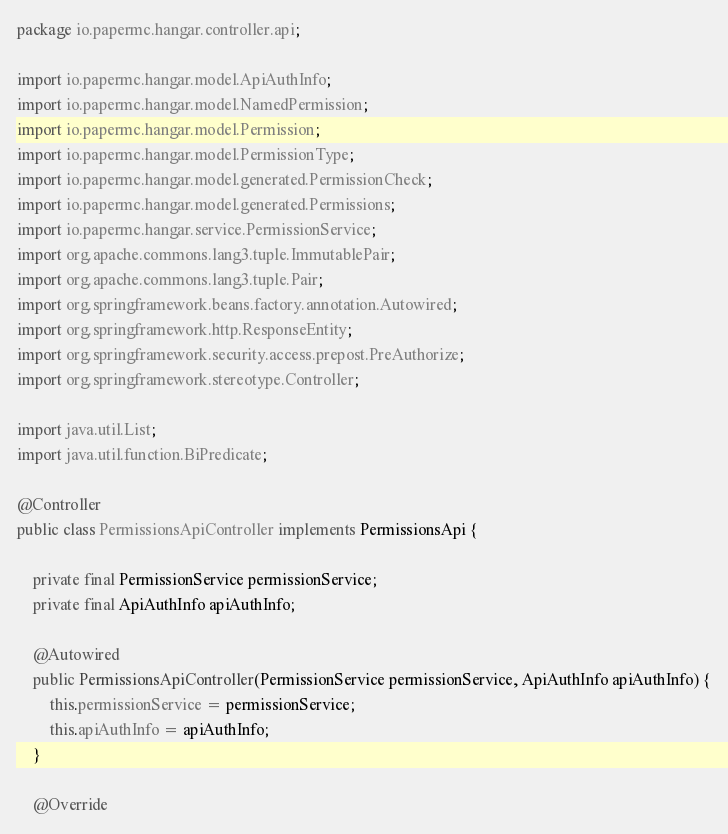<code> <loc_0><loc_0><loc_500><loc_500><_Java_>package io.papermc.hangar.controller.api;

import io.papermc.hangar.model.ApiAuthInfo;
import io.papermc.hangar.model.NamedPermission;
import io.papermc.hangar.model.Permission;
import io.papermc.hangar.model.PermissionType;
import io.papermc.hangar.model.generated.PermissionCheck;
import io.papermc.hangar.model.generated.Permissions;
import io.papermc.hangar.service.PermissionService;
import org.apache.commons.lang3.tuple.ImmutablePair;
import org.apache.commons.lang3.tuple.Pair;
import org.springframework.beans.factory.annotation.Autowired;
import org.springframework.http.ResponseEntity;
import org.springframework.security.access.prepost.PreAuthorize;
import org.springframework.stereotype.Controller;

import java.util.List;
import java.util.function.BiPredicate;

@Controller
public class PermissionsApiController implements PermissionsApi {

    private final PermissionService permissionService;
    private final ApiAuthInfo apiAuthInfo;

    @Autowired
    public PermissionsApiController(PermissionService permissionService, ApiAuthInfo apiAuthInfo) {
        this.permissionService = permissionService;
        this.apiAuthInfo = apiAuthInfo;
    }

    @Override</code> 